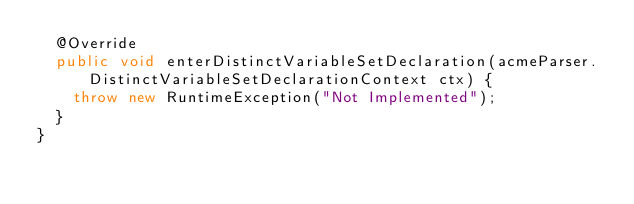Convert code to text. <code><loc_0><loc_0><loc_500><loc_500><_Java_>	@Override
	public void enterDistinctVariableSetDeclaration(acmeParser.DistinctVariableSetDeclarationContext ctx) {
		throw new RuntimeException("Not Implemented");
	}
}
</code> 